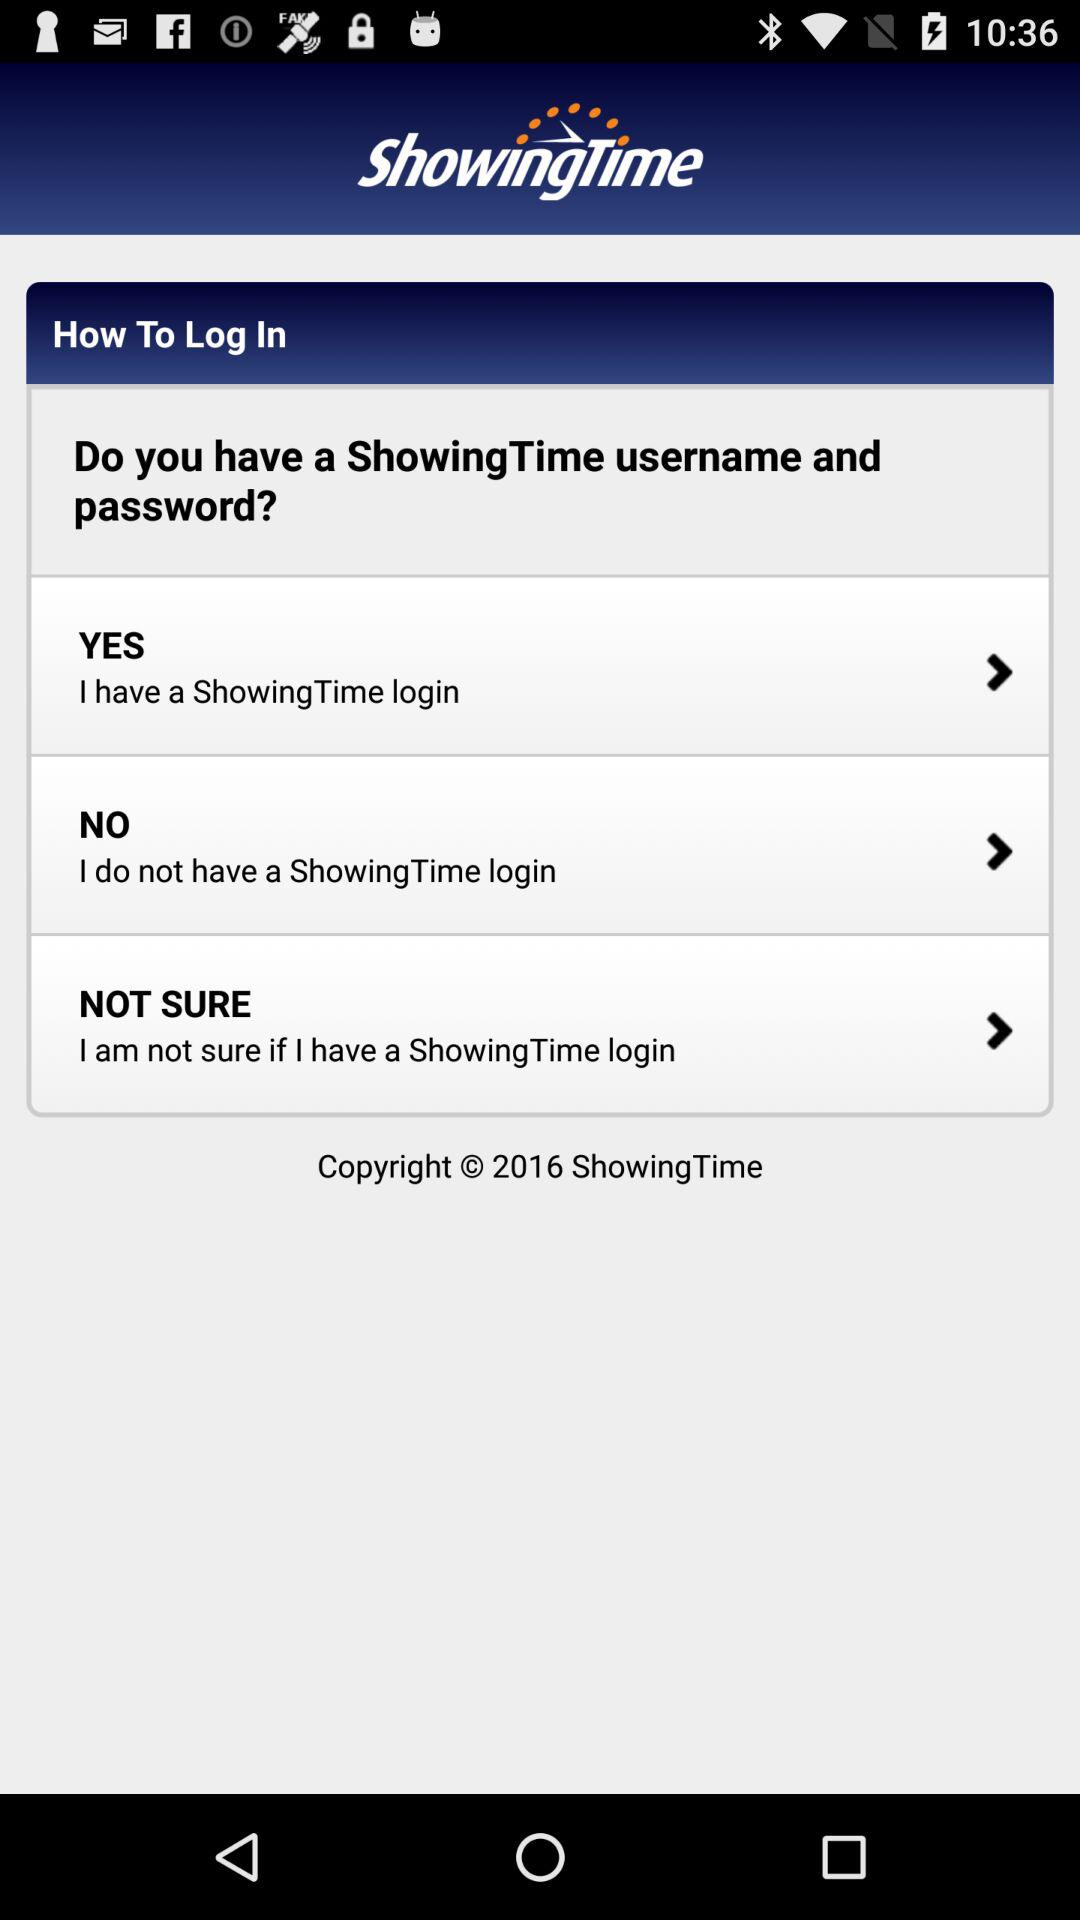How many options are there to log into ShowingTime?
Answer the question using a single word or phrase. 3 